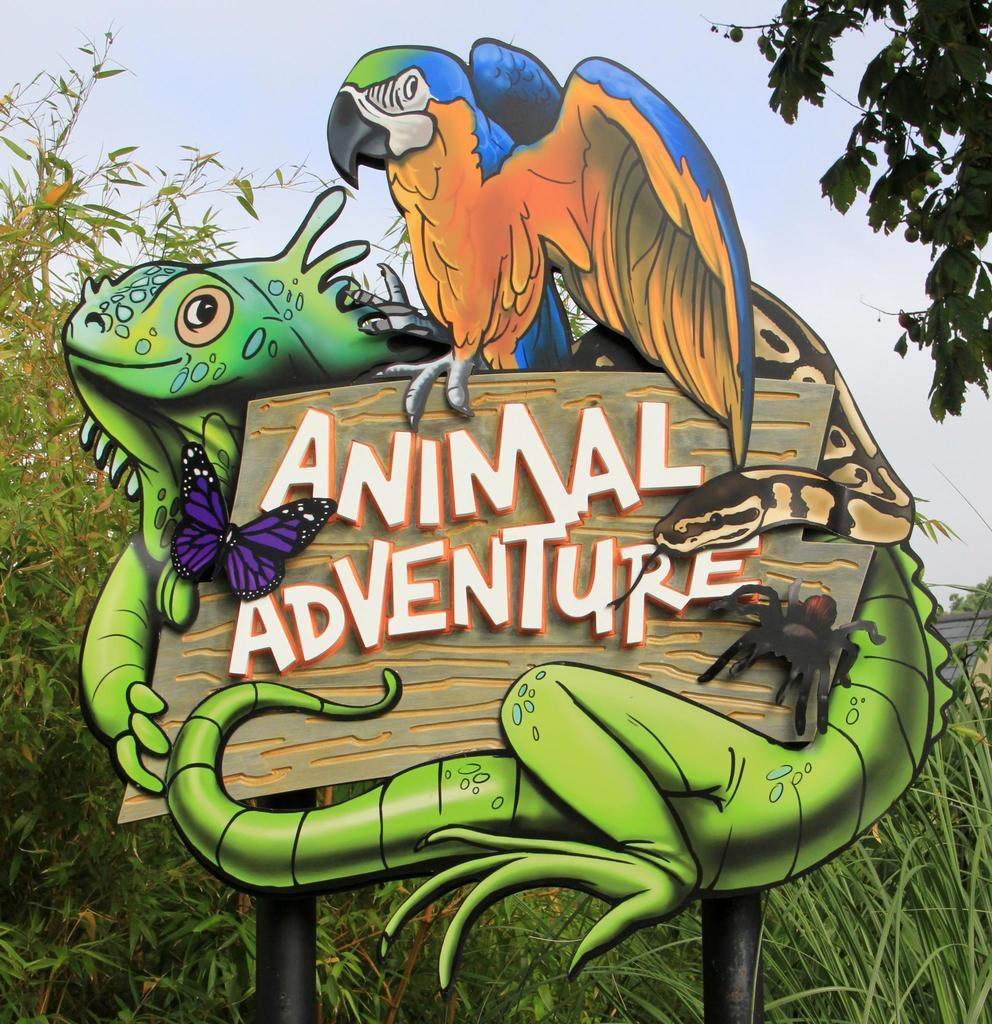What is depicted on the board in the image? There is a board with different animals in the image. What type of natural environment can be seen in the image? There are trees visible in the image, indicating a natural setting. What is visible at the top of the image? The sky is visible at the top of the image. What type of cheese is being used to create the yarn in the image? There is no cheese or yarn present in the image; it features a board with different animals and a natural setting with trees and the sky. 